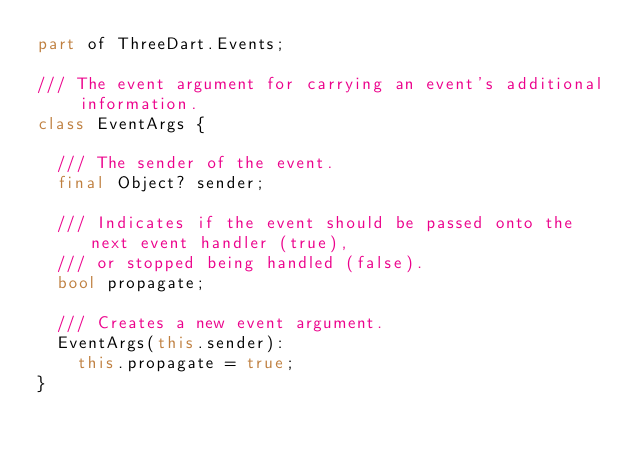<code> <loc_0><loc_0><loc_500><loc_500><_Dart_>part of ThreeDart.Events;

/// The event argument for carrying an event's additional information.
class EventArgs {

  /// The sender of the event.
  final Object? sender;

  /// Indicates if the event should be passed onto the next event handler (true),
  /// or stopped being handled (false).
  bool propagate;

  /// Creates a new event argument.
  EventArgs(this.sender):
    this.propagate = true;
}
</code> 